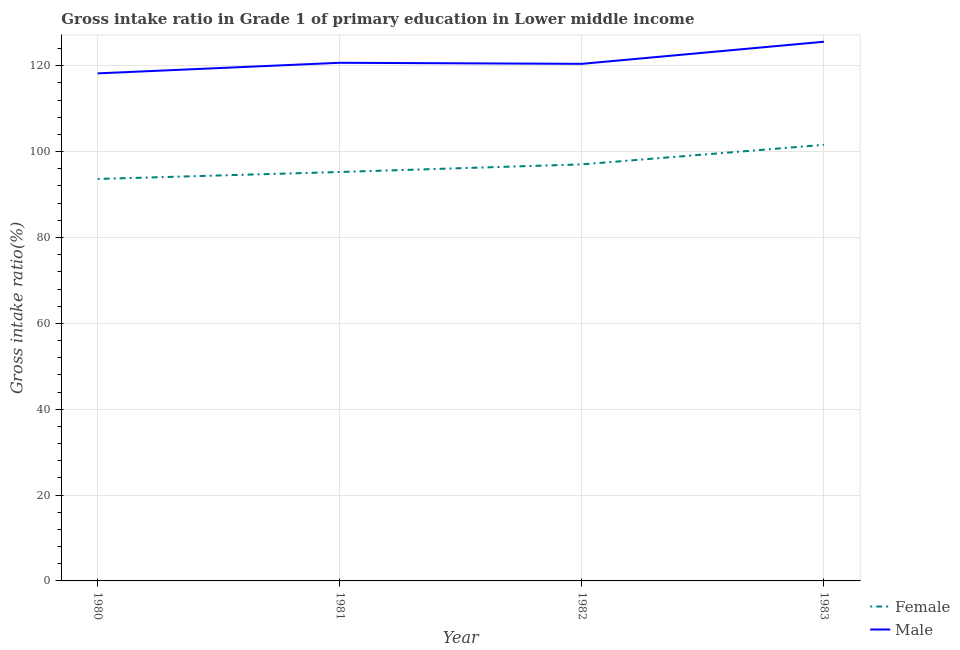How many different coloured lines are there?
Your response must be concise. 2. Does the line corresponding to gross intake ratio(female) intersect with the line corresponding to gross intake ratio(male)?
Ensure brevity in your answer.  No. What is the gross intake ratio(male) in 1983?
Offer a terse response. 125.6. Across all years, what is the maximum gross intake ratio(female)?
Offer a terse response. 101.58. Across all years, what is the minimum gross intake ratio(female)?
Provide a succinct answer. 93.63. In which year was the gross intake ratio(female) maximum?
Offer a terse response. 1983. What is the total gross intake ratio(female) in the graph?
Offer a terse response. 387.51. What is the difference between the gross intake ratio(male) in 1981 and that in 1983?
Provide a succinct answer. -4.9. What is the difference between the gross intake ratio(male) in 1980 and the gross intake ratio(female) in 1982?
Ensure brevity in your answer.  21.2. What is the average gross intake ratio(female) per year?
Your response must be concise. 96.88. In the year 1983, what is the difference between the gross intake ratio(female) and gross intake ratio(male)?
Your response must be concise. -24.02. What is the ratio of the gross intake ratio(female) in 1980 to that in 1982?
Offer a very short reply. 0.96. What is the difference between the highest and the second highest gross intake ratio(male)?
Provide a succinct answer. 4.9. What is the difference between the highest and the lowest gross intake ratio(male)?
Provide a short and direct response. 7.37. Is the sum of the gross intake ratio(female) in 1980 and 1981 greater than the maximum gross intake ratio(male) across all years?
Provide a short and direct response. Yes. Is the gross intake ratio(female) strictly greater than the gross intake ratio(male) over the years?
Provide a short and direct response. No. How many years are there in the graph?
Ensure brevity in your answer.  4. Are the values on the major ticks of Y-axis written in scientific E-notation?
Ensure brevity in your answer.  No. Does the graph contain grids?
Offer a very short reply. Yes. Where does the legend appear in the graph?
Offer a very short reply. Bottom right. How many legend labels are there?
Your answer should be very brief. 2. How are the legend labels stacked?
Make the answer very short. Vertical. What is the title of the graph?
Your answer should be very brief. Gross intake ratio in Grade 1 of primary education in Lower middle income. What is the label or title of the Y-axis?
Your answer should be compact. Gross intake ratio(%). What is the Gross intake ratio(%) of Female in 1980?
Your answer should be very brief. 93.63. What is the Gross intake ratio(%) in Male in 1980?
Offer a very short reply. 118.23. What is the Gross intake ratio(%) of Female in 1981?
Provide a short and direct response. 95.26. What is the Gross intake ratio(%) of Male in 1981?
Your answer should be very brief. 120.7. What is the Gross intake ratio(%) of Female in 1982?
Your answer should be very brief. 97.03. What is the Gross intake ratio(%) of Male in 1982?
Provide a short and direct response. 120.45. What is the Gross intake ratio(%) of Female in 1983?
Provide a succinct answer. 101.58. What is the Gross intake ratio(%) in Male in 1983?
Offer a terse response. 125.6. Across all years, what is the maximum Gross intake ratio(%) in Female?
Your answer should be very brief. 101.58. Across all years, what is the maximum Gross intake ratio(%) of Male?
Provide a short and direct response. 125.6. Across all years, what is the minimum Gross intake ratio(%) of Female?
Provide a short and direct response. 93.63. Across all years, what is the minimum Gross intake ratio(%) of Male?
Make the answer very short. 118.23. What is the total Gross intake ratio(%) in Female in the graph?
Your response must be concise. 387.51. What is the total Gross intake ratio(%) in Male in the graph?
Offer a very short reply. 484.98. What is the difference between the Gross intake ratio(%) in Female in 1980 and that in 1981?
Offer a very short reply. -1.62. What is the difference between the Gross intake ratio(%) of Male in 1980 and that in 1981?
Your answer should be compact. -2.47. What is the difference between the Gross intake ratio(%) of Female in 1980 and that in 1982?
Ensure brevity in your answer.  -3.4. What is the difference between the Gross intake ratio(%) in Male in 1980 and that in 1982?
Give a very brief answer. -2.22. What is the difference between the Gross intake ratio(%) of Female in 1980 and that in 1983?
Give a very brief answer. -7.95. What is the difference between the Gross intake ratio(%) of Male in 1980 and that in 1983?
Your answer should be very brief. -7.37. What is the difference between the Gross intake ratio(%) of Female in 1981 and that in 1982?
Make the answer very short. -1.78. What is the difference between the Gross intake ratio(%) in Male in 1981 and that in 1982?
Your response must be concise. 0.25. What is the difference between the Gross intake ratio(%) in Female in 1981 and that in 1983?
Make the answer very short. -6.33. What is the difference between the Gross intake ratio(%) of Male in 1981 and that in 1983?
Your answer should be very brief. -4.9. What is the difference between the Gross intake ratio(%) of Female in 1982 and that in 1983?
Your answer should be very brief. -4.55. What is the difference between the Gross intake ratio(%) in Male in 1982 and that in 1983?
Keep it short and to the point. -5.15. What is the difference between the Gross intake ratio(%) in Female in 1980 and the Gross intake ratio(%) in Male in 1981?
Ensure brevity in your answer.  -27.06. What is the difference between the Gross intake ratio(%) in Female in 1980 and the Gross intake ratio(%) in Male in 1982?
Your answer should be very brief. -26.82. What is the difference between the Gross intake ratio(%) of Female in 1980 and the Gross intake ratio(%) of Male in 1983?
Your response must be concise. -31.97. What is the difference between the Gross intake ratio(%) in Female in 1981 and the Gross intake ratio(%) in Male in 1982?
Provide a short and direct response. -25.19. What is the difference between the Gross intake ratio(%) in Female in 1981 and the Gross intake ratio(%) in Male in 1983?
Ensure brevity in your answer.  -30.34. What is the difference between the Gross intake ratio(%) in Female in 1982 and the Gross intake ratio(%) in Male in 1983?
Provide a short and direct response. -28.57. What is the average Gross intake ratio(%) in Female per year?
Your answer should be compact. 96.88. What is the average Gross intake ratio(%) in Male per year?
Keep it short and to the point. 121.24. In the year 1980, what is the difference between the Gross intake ratio(%) in Female and Gross intake ratio(%) in Male?
Provide a short and direct response. -24.6. In the year 1981, what is the difference between the Gross intake ratio(%) of Female and Gross intake ratio(%) of Male?
Give a very brief answer. -25.44. In the year 1982, what is the difference between the Gross intake ratio(%) in Female and Gross intake ratio(%) in Male?
Ensure brevity in your answer.  -23.42. In the year 1983, what is the difference between the Gross intake ratio(%) of Female and Gross intake ratio(%) of Male?
Your answer should be compact. -24.02. What is the ratio of the Gross intake ratio(%) in Female in 1980 to that in 1981?
Ensure brevity in your answer.  0.98. What is the ratio of the Gross intake ratio(%) in Male in 1980 to that in 1981?
Your answer should be very brief. 0.98. What is the ratio of the Gross intake ratio(%) in Female in 1980 to that in 1982?
Ensure brevity in your answer.  0.96. What is the ratio of the Gross intake ratio(%) in Male in 1980 to that in 1982?
Ensure brevity in your answer.  0.98. What is the ratio of the Gross intake ratio(%) of Female in 1980 to that in 1983?
Provide a succinct answer. 0.92. What is the ratio of the Gross intake ratio(%) in Male in 1980 to that in 1983?
Provide a short and direct response. 0.94. What is the ratio of the Gross intake ratio(%) of Female in 1981 to that in 1982?
Offer a very short reply. 0.98. What is the ratio of the Gross intake ratio(%) in Male in 1981 to that in 1982?
Offer a very short reply. 1. What is the ratio of the Gross intake ratio(%) in Female in 1981 to that in 1983?
Offer a very short reply. 0.94. What is the ratio of the Gross intake ratio(%) in Female in 1982 to that in 1983?
Ensure brevity in your answer.  0.96. What is the difference between the highest and the second highest Gross intake ratio(%) of Female?
Give a very brief answer. 4.55. What is the difference between the highest and the second highest Gross intake ratio(%) in Male?
Your response must be concise. 4.9. What is the difference between the highest and the lowest Gross intake ratio(%) in Female?
Your answer should be compact. 7.95. What is the difference between the highest and the lowest Gross intake ratio(%) in Male?
Your answer should be very brief. 7.37. 